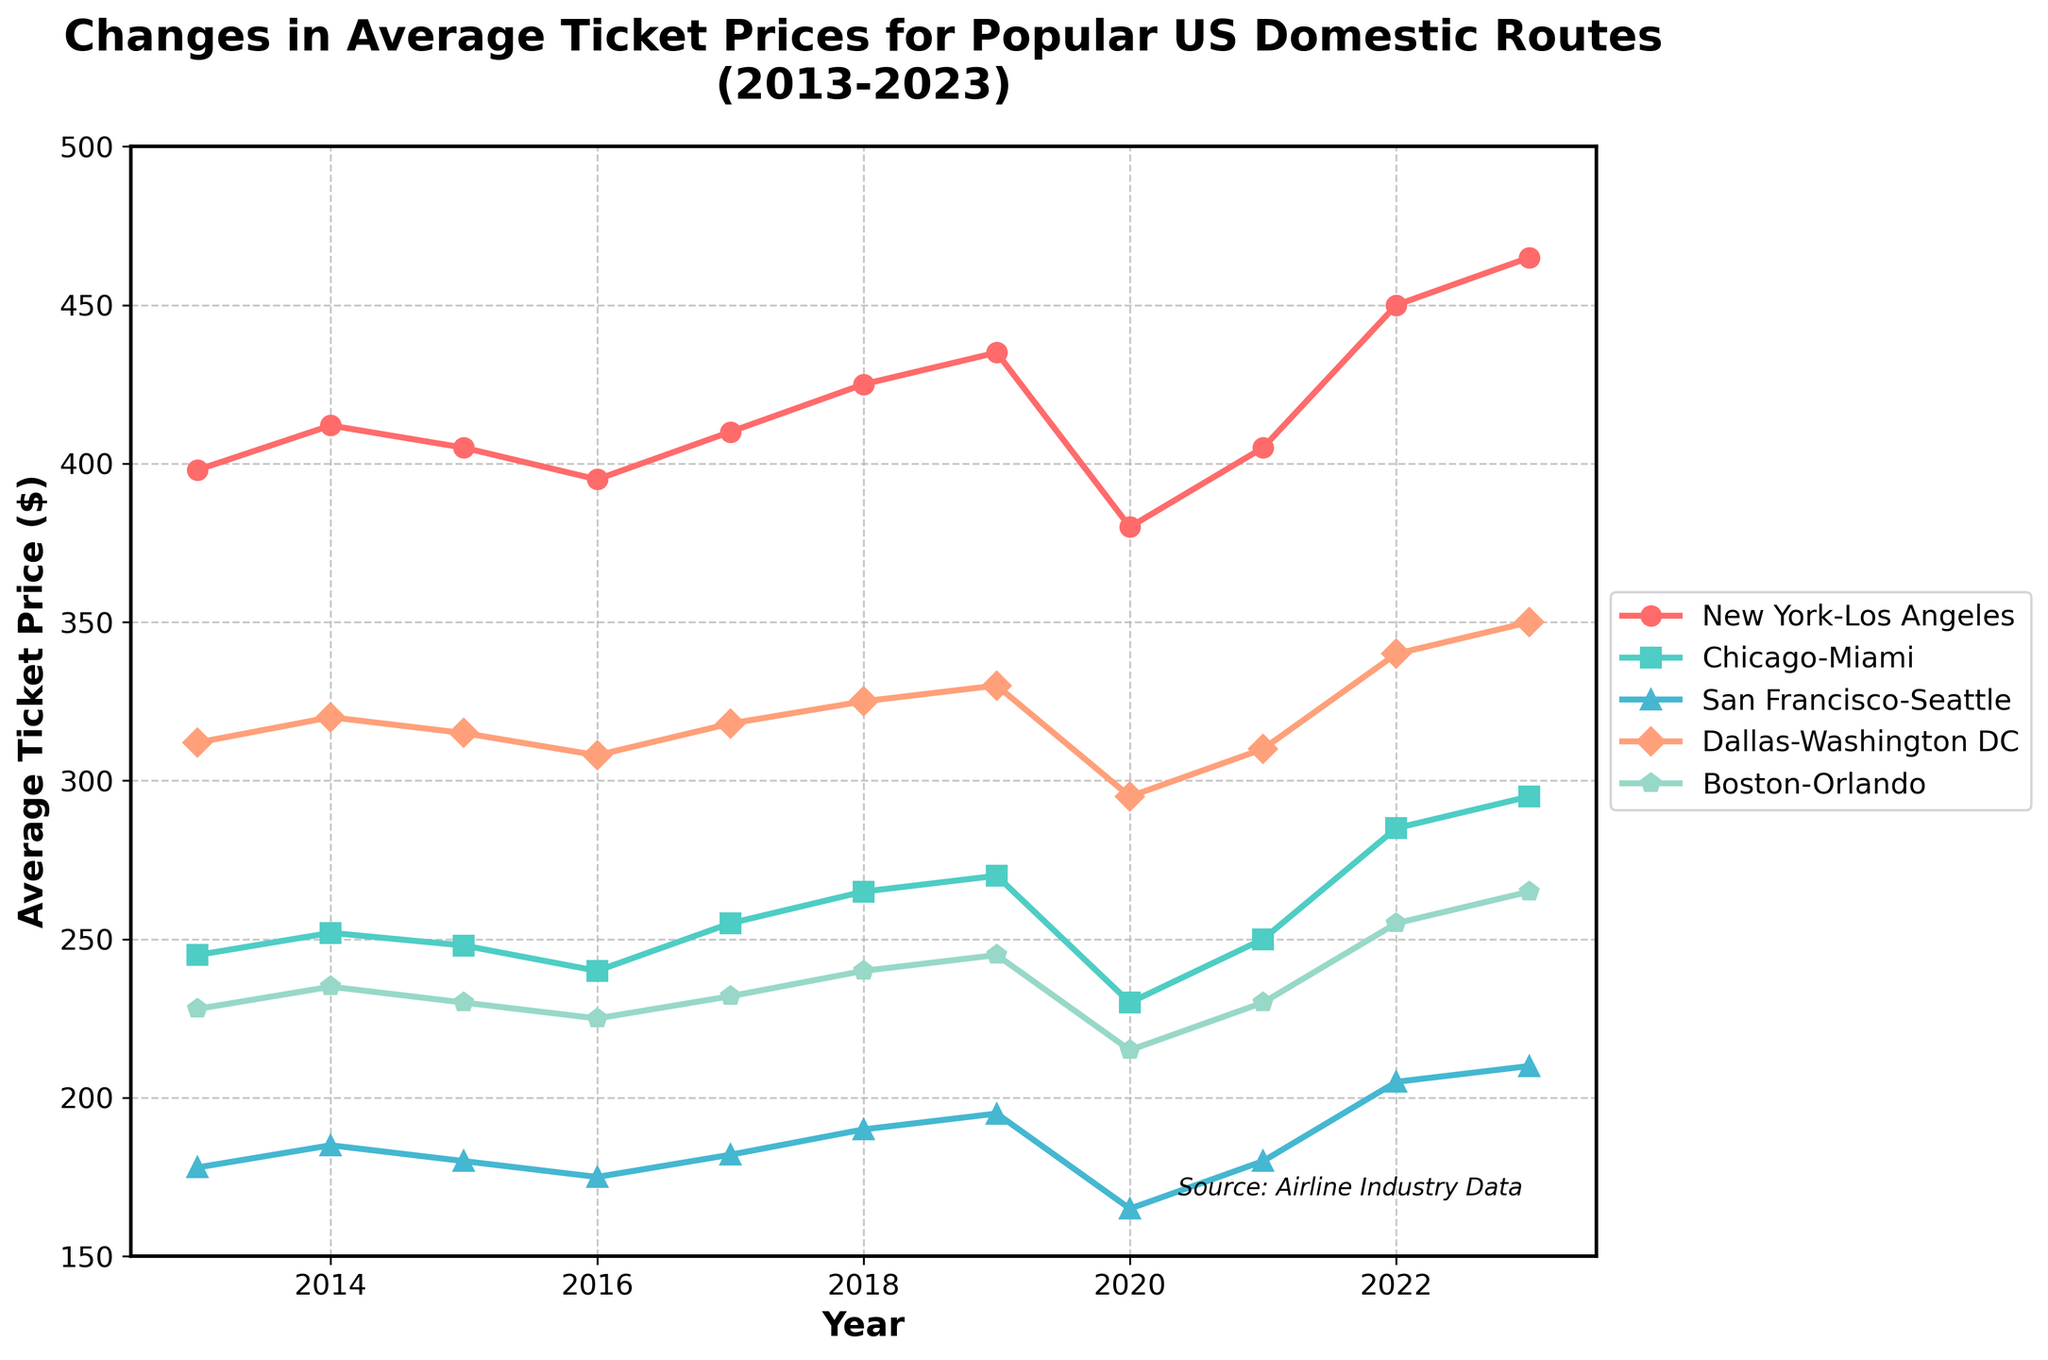Which route had the highest average ticket price in 2023? To find the route with the highest average ticket price in 2023, we look at the values for each route in that year. The values are: New York-Los Angeles: $465, Chicago-Miami: $295, San Francisco-Seattle: $210, Dallas-Washington DC: $350, Boston-Orlando: $265. The highest value is $465 for New York-Los Angeles.
Answer: New York-Los Angeles How did the ticket prices for the Chicago-Miami route change from 2013 to 2020? Refer to the values for the Chicago-Miami route in 2013 and 2020: In 2013 the price was $245 and in 2020 it was $230. To find the change, subtract $245 from $230, resulting in a decrease of $15.
Answer: Decreased by $15 What is the general trend of average ticket prices for the San Francisco-Seattle route? Observing the San Francisco-Seattle line from 2013 to 2023, in 2013 the price was $178 and it increased to $210 by 2023 with some fluctuations in between. Overall, the trend shows an increase.
Answer: Increasing Between which consecutive years did the Boston-Orlando route see the most significant price increase? We need to calculate the annual changes for Boston-Orlando values each year: 2014 ($235-$228 = +$7), 2015 ($230-$235 = -$5), 2016 ($225-$230 = -$5), 2017 ($232-$225 = +$7), 2018 ($240-$232 = +$8), 2019 ($245-$240 = +$5), 2020 ($215-$245 = -$30), 2021 ($230-$215 = +$15), 2022 ($255-$230 = +$25), 2023 ($265-$255 = +$10). The largest increase is from 2021 to 2022 by $25.
Answer: 2021 to 2022 Which route had the largest decrease in average ticket price in any single year? Calculate the yearly changes for each route and note the largest decrease: New York-Los Angeles in 2020 (decreased by $55), Chicago-Miami in 2020 (decreased by $40), San Francisco-Seattle in 2020 (decreased by $30), Dallas-Washington DC in 2020 (decreased by $35), Boston-Orlando in 2020 (decreased by $30). The largest decrease is in the New York-Los Angeles route in 2020 by $55.
Answer: New York-Los Angeles in 2020 Which route had the most stable average ticket price over the decade? Examining the fluctuations in each line: New York-Los Angeles (fluctuations of up to $85), Chicago-Miami (fluctuations of up to $65), San Francisco-Seattle (fluctuations of up to $45), Dallas-Washington DC (fluctuations of up to $57), Boston-Orlando (fluctuations of up to $50). The San Francisco-Seattle route shows the smallest fluctuation compared to others.
Answer: San Francisco-Seattle By how much did the average ticket price for New York-Los Angeles increase from 2020 to 2023? Check the New York-Los Angeles values for 2020 ($380) and 2023 ($465). Subtract $380 from $465 which gives us an increase of $85.
Answer: $85 